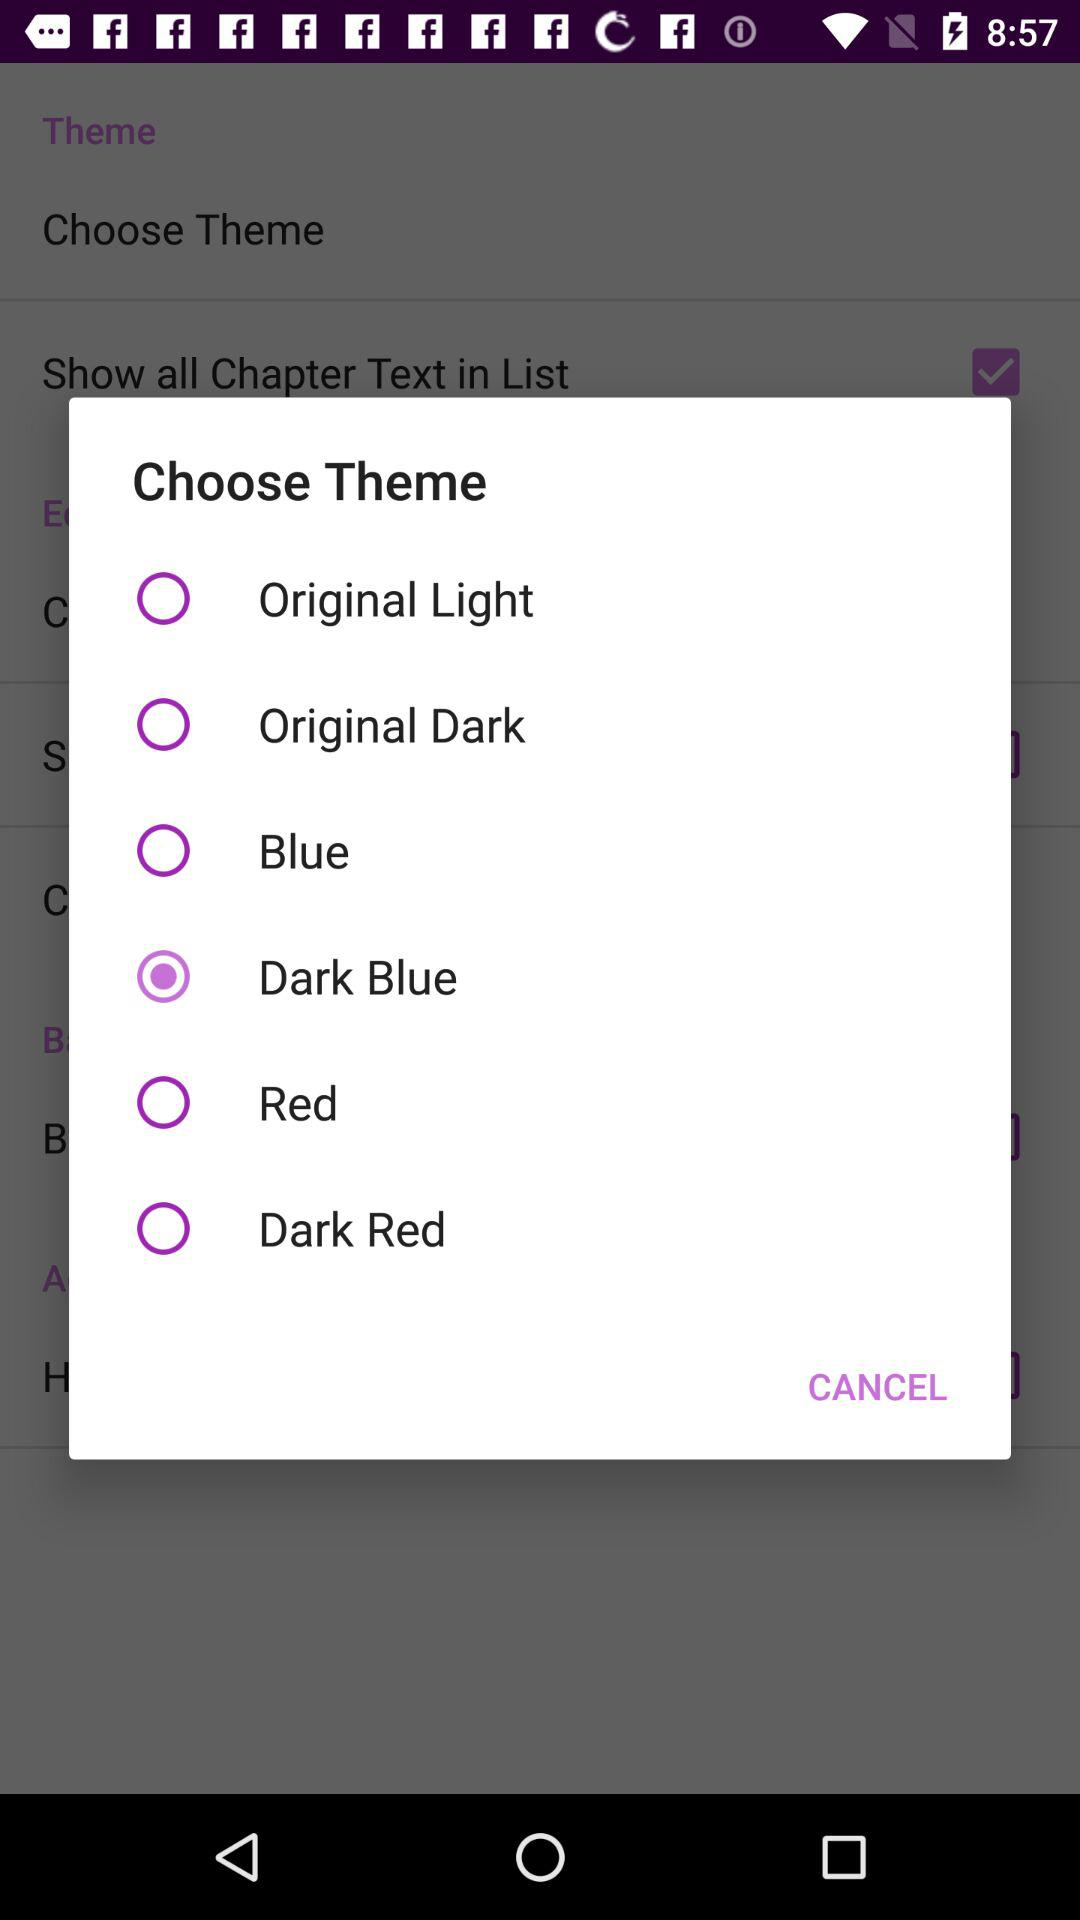How many themes are there in total?
Answer the question using a single word or phrase. 6 